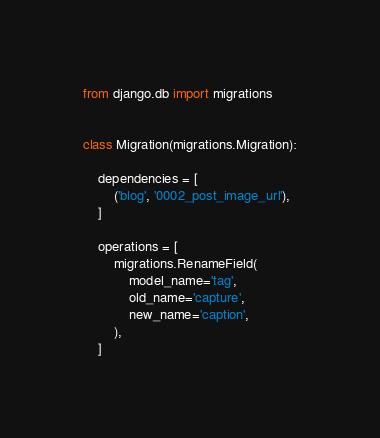Convert code to text. <code><loc_0><loc_0><loc_500><loc_500><_Python_>
from django.db import migrations


class Migration(migrations.Migration):

    dependencies = [
        ('blog', '0002_post_image_url'),
    ]

    operations = [
        migrations.RenameField(
            model_name='tag',
            old_name='capture',
            new_name='caption',
        ),
    ]
</code> 